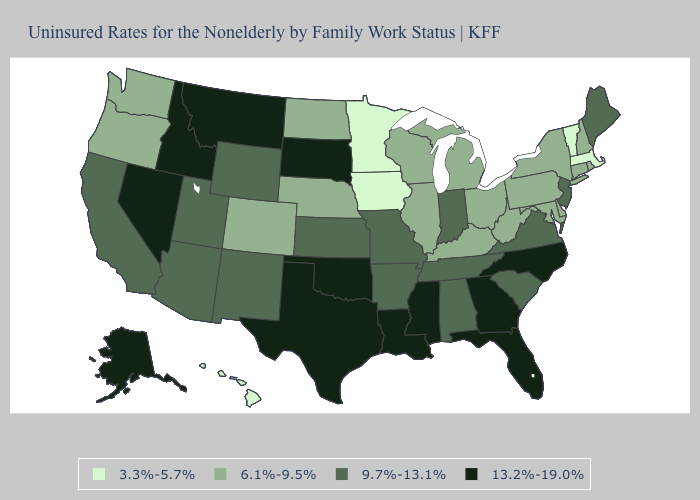What is the value of Missouri?
Give a very brief answer. 9.7%-13.1%. What is the highest value in the USA?
Keep it brief. 13.2%-19.0%. Is the legend a continuous bar?
Answer briefly. No. Which states have the lowest value in the South?
Give a very brief answer. Delaware, Kentucky, Maryland, West Virginia. Among the states that border Kentucky , which have the highest value?
Write a very short answer. Indiana, Missouri, Tennessee, Virginia. What is the value of Wisconsin?
Answer briefly. 6.1%-9.5%. Name the states that have a value in the range 3.3%-5.7%?
Short answer required. Hawaii, Iowa, Massachusetts, Minnesota, Vermont. Which states have the lowest value in the USA?
Concise answer only. Hawaii, Iowa, Massachusetts, Minnesota, Vermont. Does Washington have the same value as Maryland?
Quick response, please. Yes. What is the lowest value in the South?
Short answer required. 6.1%-9.5%. What is the value of Arkansas?
Quick response, please. 9.7%-13.1%. Among the states that border California , does Arizona have the lowest value?
Write a very short answer. No. Does the first symbol in the legend represent the smallest category?
Quick response, please. Yes. Does the first symbol in the legend represent the smallest category?
Answer briefly. Yes. Name the states that have a value in the range 9.7%-13.1%?
Be succinct. Alabama, Arizona, Arkansas, California, Indiana, Kansas, Maine, Missouri, New Jersey, New Mexico, South Carolina, Tennessee, Utah, Virginia, Wyoming. 